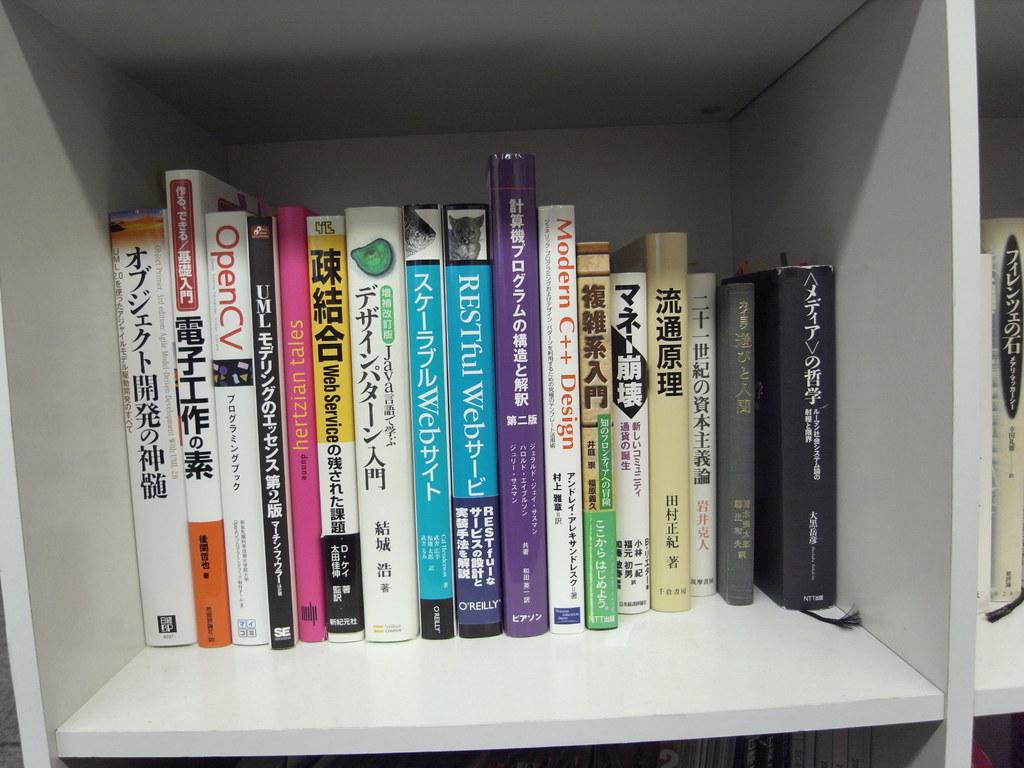Provide a one-sentence caption for the provided image. Restful web and other books sitting near each other. 